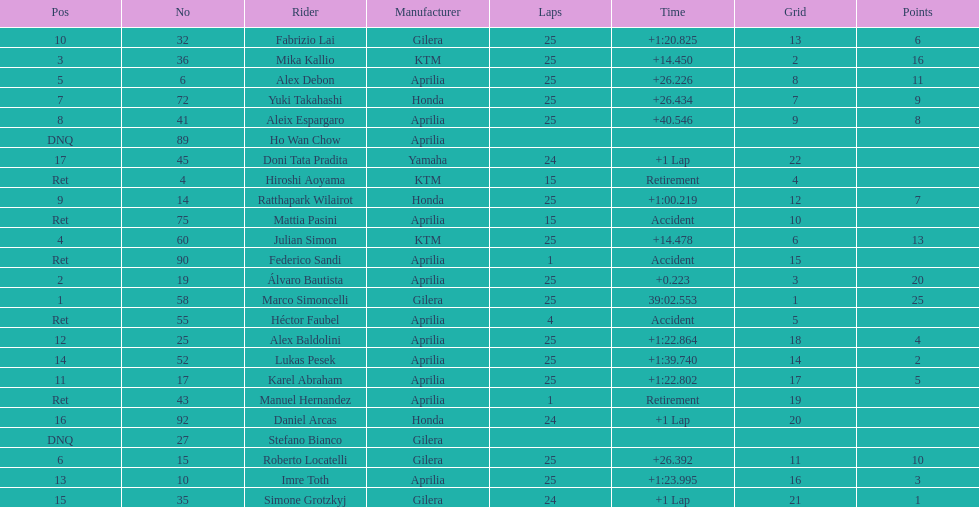Who is marco simoncelli's manufacturer Gilera. 